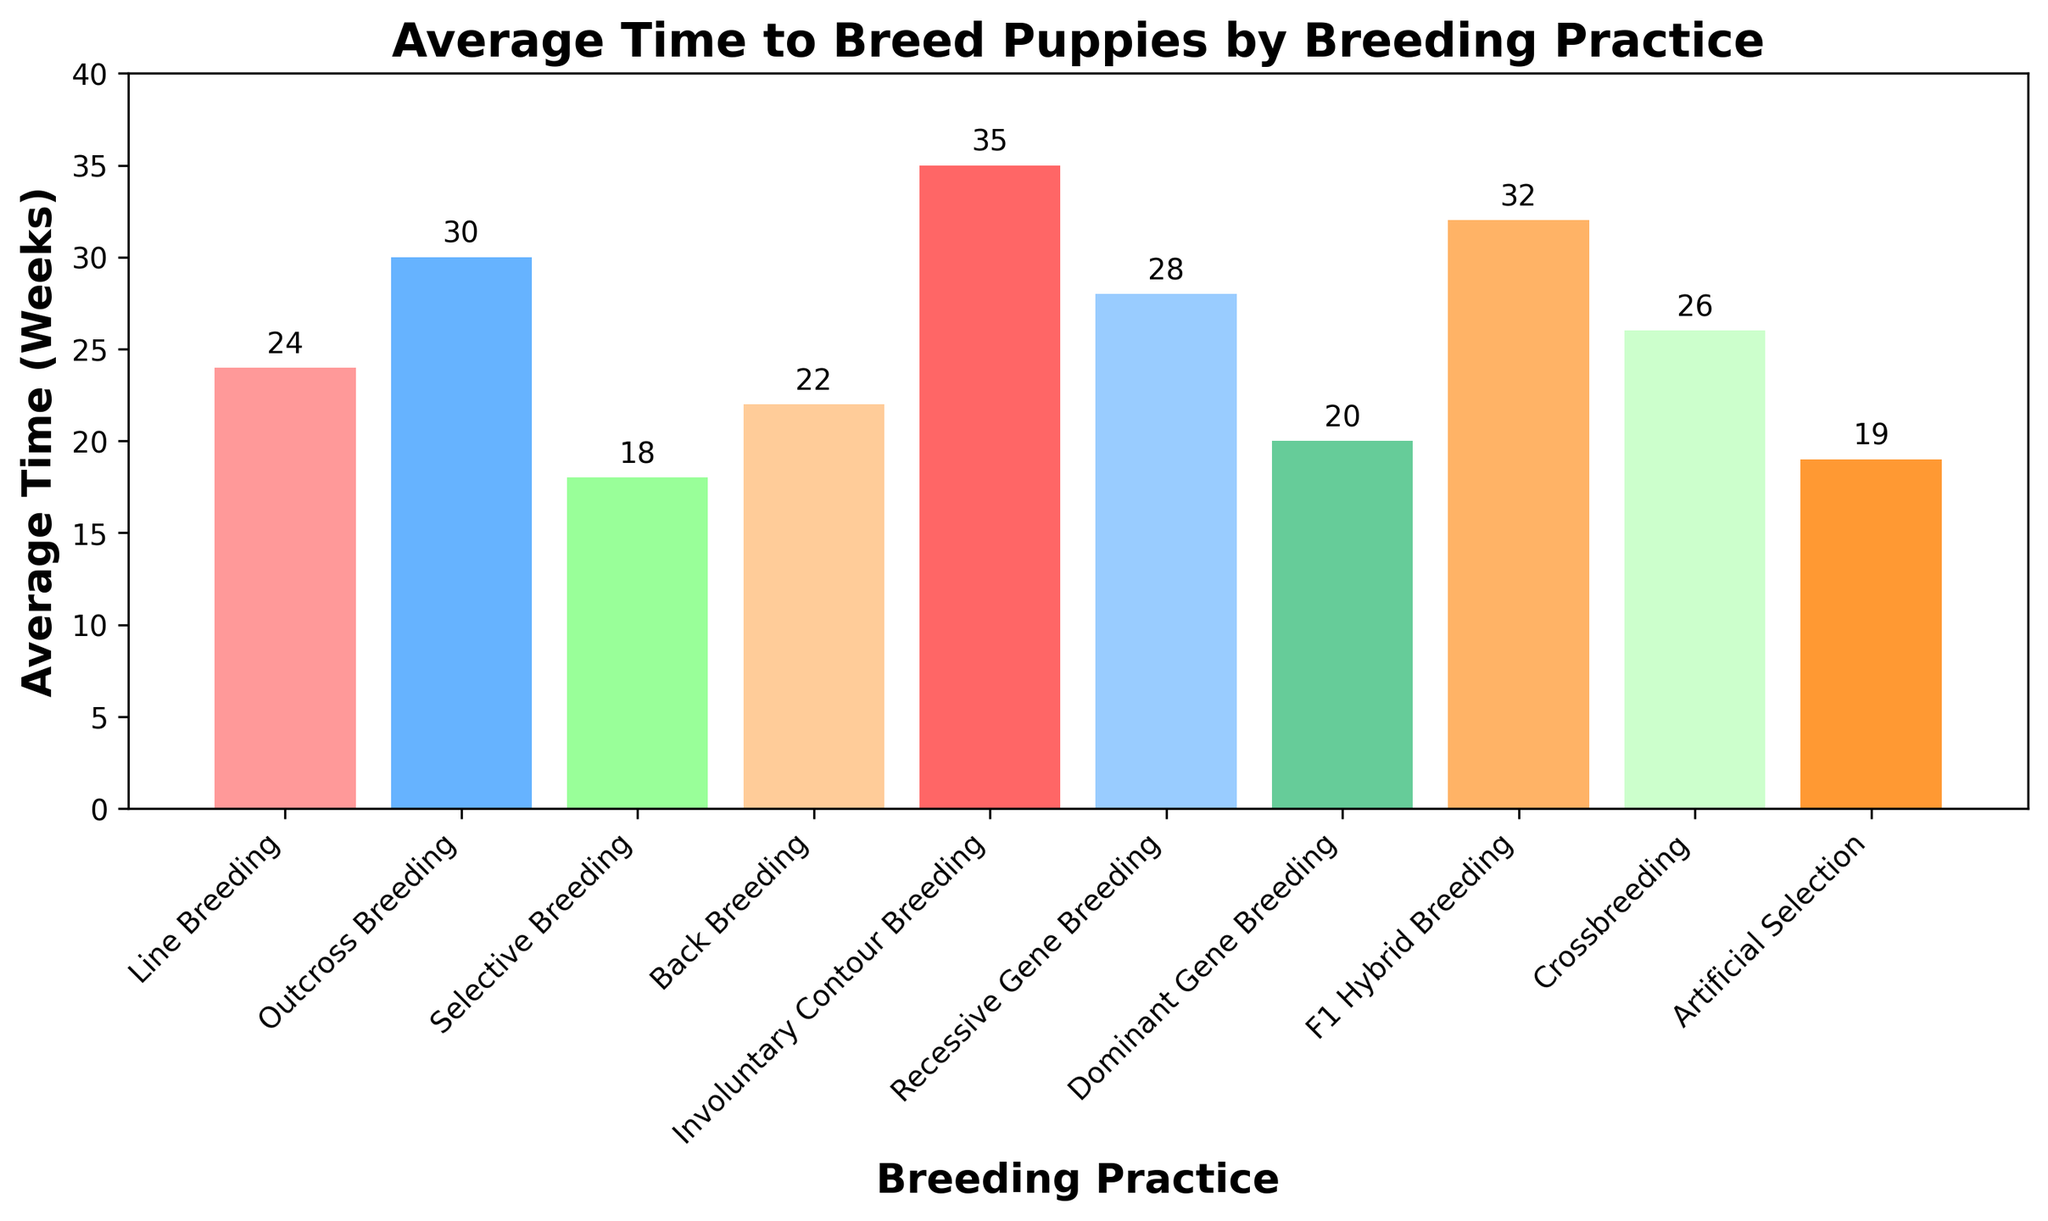Which breeding practice has the shortest average time? To find the shortest average time, inspect the heights of the bars and identify the smallest one, which corresponds to Selective Breeding at 18 weeks.
Answer: Selective Breeding Which breeding practice has the longest average time? To determine the longest average time, look for the tallest bar, which corresponds to Involuntary Contour Breeding at 35 weeks.
Answer: Involuntary Contour Breeding What is the difference in average time between Line Breeding and Outcross Breeding? Line Breeding takes 24 weeks and Outcross Breeding takes 30 weeks. Compute the difference as 30 - 24.
Answer: 6 weeks Which breeding practices take less than 25 weeks on average? Identify all bars with heights less than 25. These practices are Line Breeding (24 weeks), Selective Breeding (18 weeks), Back Breeding (22 weeks), Dominant Gene Breeding (20 weeks), and Artificial Selection (19 weeks).
Answer: Line Breeding, Selective Breeding, Back Breeding, Dominant Gene Breeding, Artificial Selection How much longer on average does F1 Hybrid Breeding take compared to Crossbreeding? F1 Hybrid Breeding takes 32 weeks and Crossbreeding takes 26 weeks. Compute the difference as 32 - 26.
Answer: 6 weeks What is the average time required for Selective Breeding, Artificial Selection, and Dominant Gene Breeding? Add the average times for these practices (18 + 19 + 20) and divide by 3. Calculation: (18 + 19 + 20) / 3 = 57 / 3.
Answer: 19 weeks Which two breeding practices have the closest average times? Compare the average times for all practices and find the smallest difference. Line Breeding (24 weeks) and Crossbreeding (26 weeks) have a difference of 2 weeks.
Answer: Line Breeding and Crossbreeding What is the total average time for Involuntary Contour Breeding and Recessive Gene Breeding combined? Sum the average times for these two practices. Involuntary Contour Breeding is 35 weeks and Recessive Gene Breeding is 28 weeks. Calculation: 35 + 28.
Answer: 63 weeks Which colored bar corresponds to the practice with the second-shortest average time? Identify the practice with the second-shortest average time, which is Artificial Selection at 19 weeks. The bar is orange.
Answer: Orange 